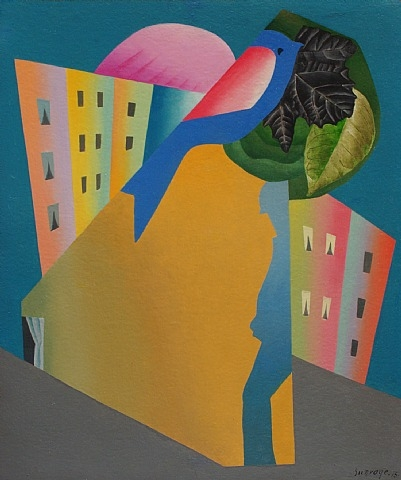What might the bird and the green leaf symbolize in this artwork? The bird paired with the green leaf can be interpreted as symbols of nature and renewal. In the context of the abstract forms surrounding it, this pairing might suggest themes of hope, regeneration, or perhaps a commentary on the human condition within natural and built environments. The vibrant colors used for these symbols reinforce their significance, providing a visual anchor in the surreal landscape. 